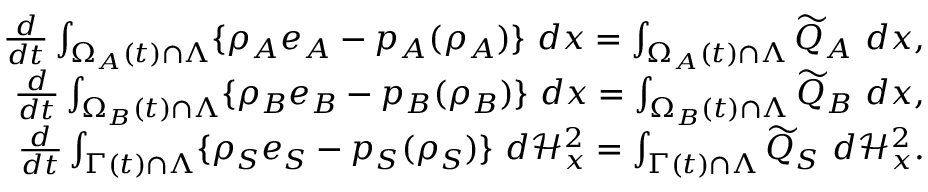Convert formula to latex. <formula><loc_0><loc_0><loc_500><loc_500>\begin{array} { r } { \frac { d } { d t } \int _ { \Omega _ { A } ( t ) \cap \Lambda } \{ \rho _ { A } e _ { A } - p _ { A } ( \rho _ { A } ) \} { \ } d x = \int _ { \Omega _ { A } ( t ) \cap \Lambda } \widetilde { Q } _ { A } { \ } d x , } \\ { \frac { d } { d t } \int _ { \Omega _ { B } ( t ) \cap \Lambda } \{ \rho _ { B } e _ { B } - p _ { B } ( \rho _ { B } ) \} { \ } d x = \int _ { \Omega _ { B } ( t ) \cap \Lambda } \widetilde { Q } _ { B } { \ } d x , } \\ { \frac { d } { d t } \int _ { \Gamma ( t ) \cap \Lambda } \{ \rho _ { S } e _ { S } - p _ { S } ( \rho _ { S } ) \} { \ } d \mathcal { H } _ { x } ^ { 2 } = \int _ { \Gamma ( t ) \cap \Lambda } \widetilde { Q } _ { S } { \ } d \mathcal { H } _ { x } ^ { 2 } . } \end{array}</formula> 